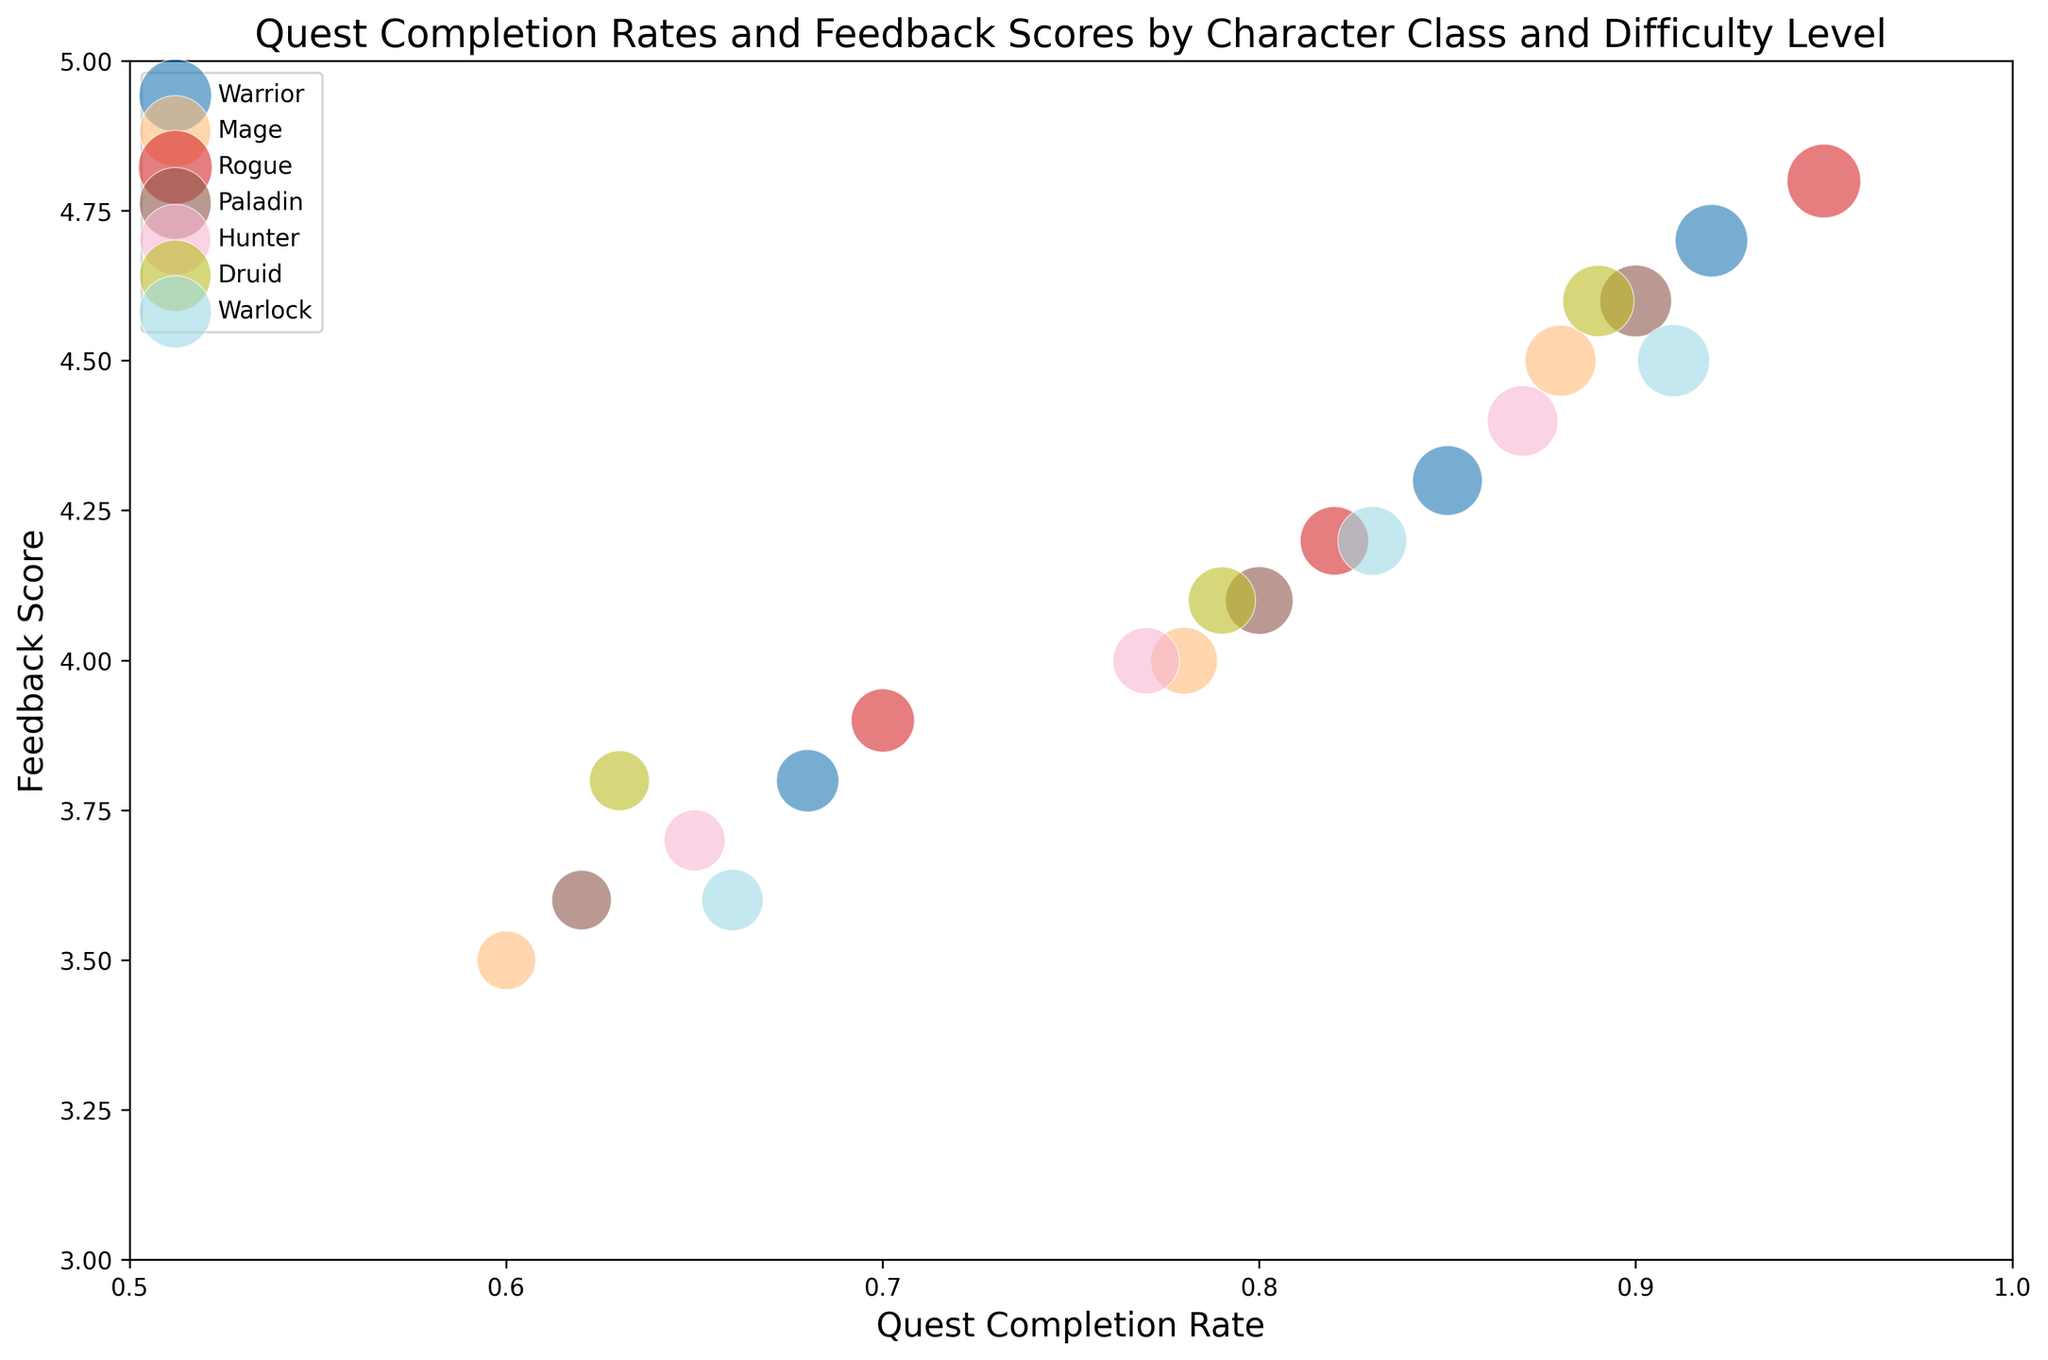What's the quest completion rate for the Mage class at the Hard difficulty level? The Mage class at Hard difficulty level has a completion rate of 0.60 according to the data points in the figure.
Answer: 0.60 Which character class has the highest feedback score at the Normal difficulty level? By examining the feedback scores for each character class at Normal difficulty, Rogue has the highest feedback score of 4.2.
Answer: Rogue What's the average quest completion rate for the Easy difficulty level across all character classes? Sum the completion rates for all classes at Easy difficulty: 0.92 (Warrior) + 0.88 (Mage) + 0.95 (Rogue) + 0.90 (Paladin) + 0.87 (Hunter) + 0.89 (Druid) + 0.91 (Warlock) = 6.32. Then divide by the number of classes, which is 7: 6.32 / 7 = 0.90
Answer: 0.90 How does the quest completion rate for the Druid class at Normal difficulty compare to that of the Hunter class at the same difficulty? The Druid class has a completion rate of 0.79 at Normal difficulty, while the Hunter class has a rate of 0.77. Therefore, the Druid class has a higher quest completion rate (0.79 vs. 0.77).
Answer: Druid Which character class shows the greatest decrease in quest completion rate from Easy to Hard difficulty? Calculate the drop from Easy to Hard for each class: Warrior (0.92 - 0.68 = 0.24), Mage (0.88 - 0.60 = 0.28), Rogue (0.95 - 0.70 = 0.25), Paladin (0.90 - 0.62 = 0.28), Hunter (0.87 - 0.65 = 0.22), Druid (0.89 - 0.63 = 0.26), and Warlock (0.91 - 0.66 = 0.25). Both Mage and Paladin show the greatest decrease of 0.28.
Answer: Mage, Paladin Which character class has the smallest difference in feedback scores between Easy and Hard difficulty levels? Calculate the difference for each class: Warrior (4.7 - 3.8 = 0.9), Mage (4.5 - 3.5 = 1.0), Rogue (4.8 - 3.9 = 0.9), Paladin (4.6 - 3.6 = 1.0), Hunter (4.4 - 3.7 = 0.7), Druid (4.6 - 3.8 = 0.8), Warlock (4.5 - 3.6 = 0.9). Hunter has the smallest difference of 0.7.
Answer: Hunter Which character class has the largest bubble at the Easy difficulty level? The size of the bubble represents the value of BubbleSize. The class with the largest bubble at Easy difficulty is Rogue with a BubbleSize of 95.
Answer: Rogue What is the overall trend in feedback scores as the difficulty level increases from Easy to Hard? By visually examining the feedback scores for each class across difficulty levels, it is clear that feedback scores generally decrease as the difficulty increases from Easy to Hard.
Answer: Decrease Compare the quest completion rates for the Paladin class between Easy and Normal difficulty levels. The quest completion rate for the Paladin class at Easy is 0.90 and at Normal is 0.80. The rate decreases by 0.1 when moving from Easy to Normal difficulty.
Answer: Decrease by 0.1 What is the feedback score for the Warrior class at the Normal difficulty level? The Warrior class has a feedback score of 4.3 at the Normal difficulty level as indicated in the figure.
Answer: 4.3 